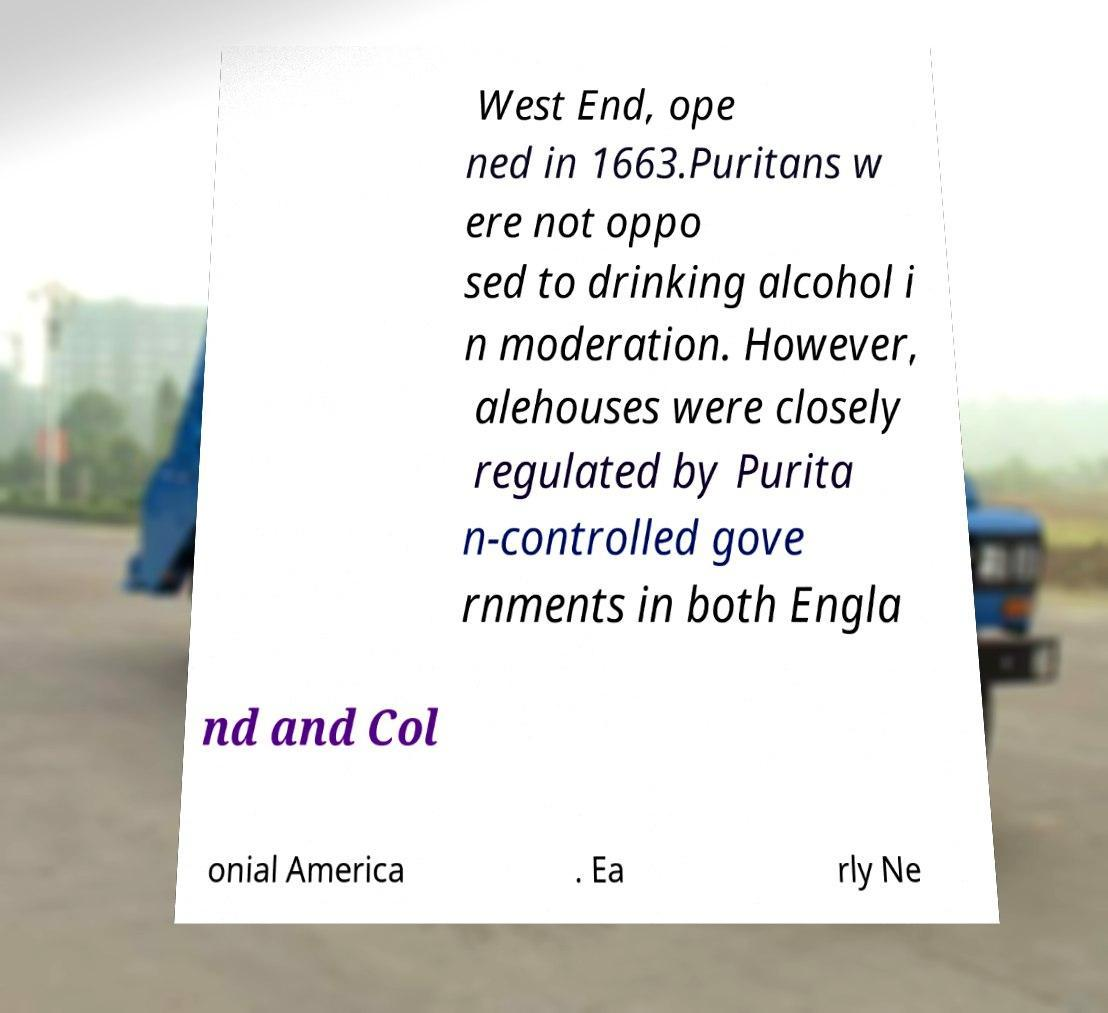Please read and relay the text visible in this image. What does it say? West End, ope ned in 1663.Puritans w ere not oppo sed to drinking alcohol i n moderation. However, alehouses were closely regulated by Purita n-controlled gove rnments in both Engla nd and Col onial America . Ea rly Ne 